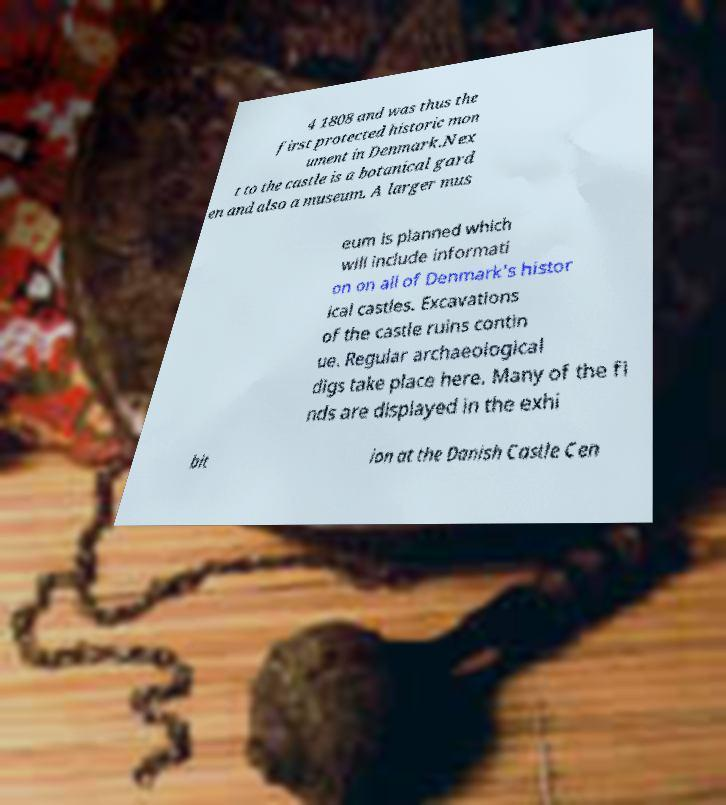For documentation purposes, I need the text within this image transcribed. Could you provide that? 4 1808 and was thus the first protected historic mon ument in Denmark.Nex t to the castle is a botanical gard en and also a museum. A larger mus eum is planned which will include informati on on all of Denmark's histor ical castles. Excavations of the castle ruins contin ue. Regular archaeological digs take place here. Many of the fi nds are displayed in the exhi bit ion at the Danish Castle Cen 